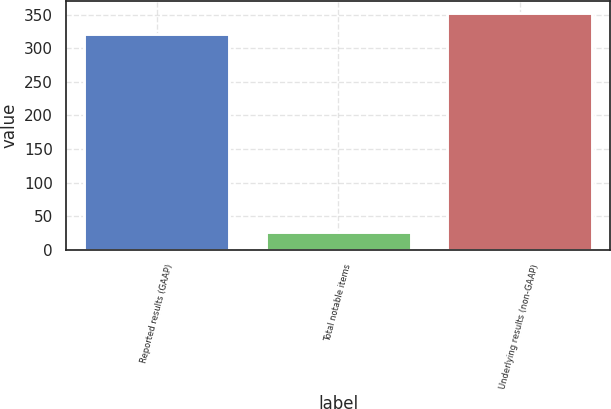Convert chart. <chart><loc_0><loc_0><loc_500><loc_500><bar_chart><fcel>Reported results (GAAP)<fcel>Total notable items<fcel>Underlying results (non-GAAP)<nl><fcel>321<fcel>26<fcel>353.1<nl></chart> 